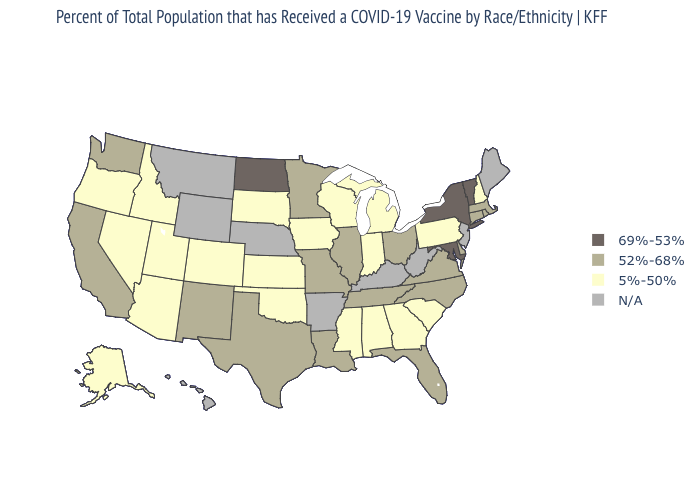Which states have the lowest value in the USA?
Quick response, please. Alabama, Alaska, Arizona, Colorado, Georgia, Idaho, Indiana, Iowa, Kansas, Michigan, Mississippi, Nevada, New Hampshire, Oklahoma, Oregon, Pennsylvania, South Carolina, South Dakota, Utah, Wisconsin. What is the lowest value in the USA?
Quick response, please. 5%-50%. Which states have the lowest value in the West?
Concise answer only. Alaska, Arizona, Colorado, Idaho, Nevada, Oregon, Utah. Among the states that border Missouri , does Kansas have the highest value?
Short answer required. No. Is the legend a continuous bar?
Write a very short answer. No. Does the map have missing data?
Keep it brief. Yes. What is the highest value in the USA?
Give a very brief answer. 69%-53%. Name the states that have a value in the range 5%-50%?
Concise answer only. Alabama, Alaska, Arizona, Colorado, Georgia, Idaho, Indiana, Iowa, Kansas, Michigan, Mississippi, Nevada, New Hampshire, Oklahoma, Oregon, Pennsylvania, South Carolina, South Dakota, Utah, Wisconsin. What is the highest value in the Northeast ?
Short answer required. 69%-53%. Does the first symbol in the legend represent the smallest category?
Write a very short answer. No. What is the value of Alaska?
Write a very short answer. 5%-50%. Name the states that have a value in the range 52%-68%?
Give a very brief answer. California, Connecticut, Delaware, Florida, Illinois, Louisiana, Massachusetts, Minnesota, Missouri, New Mexico, North Carolina, Ohio, Rhode Island, Tennessee, Texas, Virginia, Washington. Does the map have missing data?
Keep it brief. Yes. What is the value of Kentucky?
Short answer required. N/A. Which states have the lowest value in the West?
Quick response, please. Alaska, Arizona, Colorado, Idaho, Nevada, Oregon, Utah. 